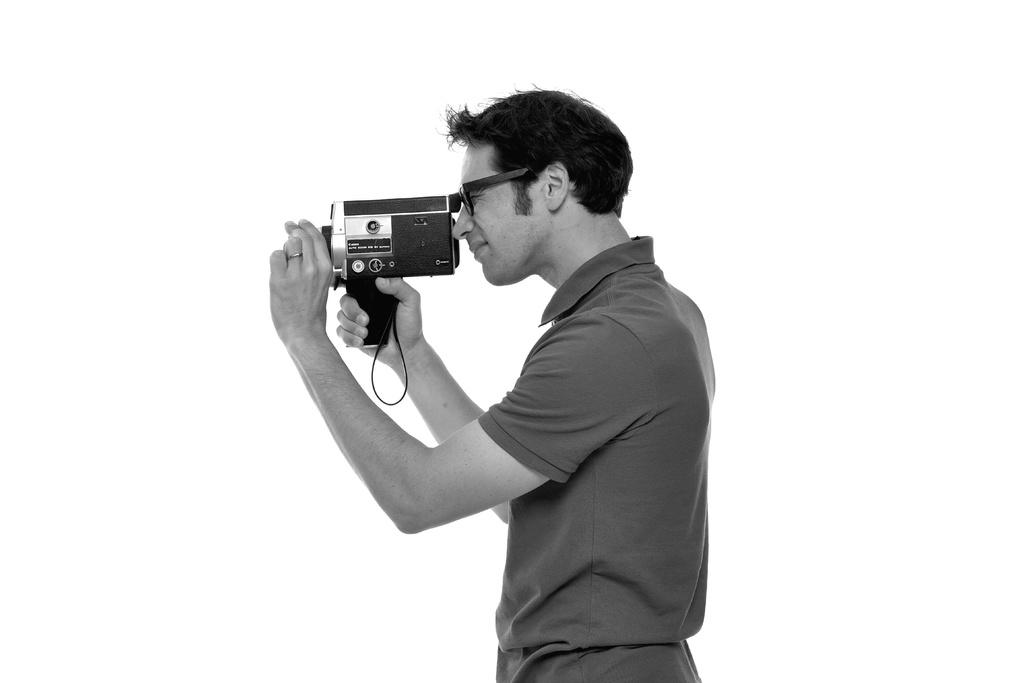What is the main subject of the image? The main subject of the image is a man. What can be observed about the man's appearance? The man is wearing spectacles and a T-shirt. What is the man holding in his hand? The man is holding a camera in his hand. What is the man doing in the image? The man is taking a picture. What is the color of the background in the image? The background of the image is white in color. What type of flower is the man holding in his hand while taking a picture? There is no flower present in the image; the man is holding a camera. Where is the lunchroom located in the image? There is no mention of a lunchroom in the image; the focus is on the man taking a picture. 